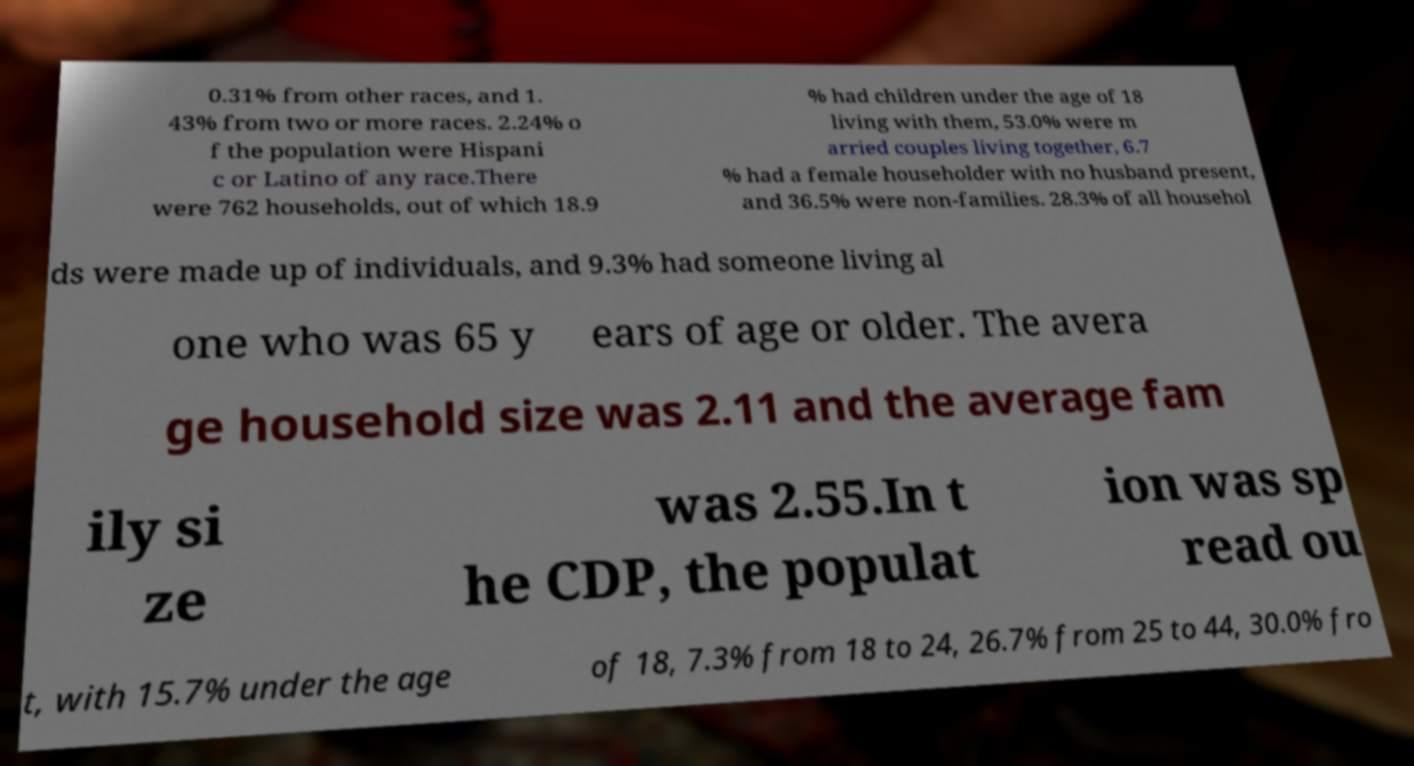Please read and relay the text visible in this image. What does it say? 0.31% from other races, and 1. 43% from two or more races. 2.24% o f the population were Hispani c or Latino of any race.There were 762 households, out of which 18.9 % had children under the age of 18 living with them, 53.0% were m arried couples living together, 6.7 % had a female householder with no husband present, and 36.5% were non-families. 28.3% of all househol ds were made up of individuals, and 9.3% had someone living al one who was 65 y ears of age or older. The avera ge household size was 2.11 and the average fam ily si ze was 2.55.In t he CDP, the populat ion was sp read ou t, with 15.7% under the age of 18, 7.3% from 18 to 24, 26.7% from 25 to 44, 30.0% fro 